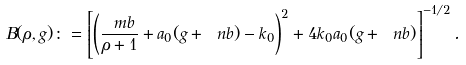<formula> <loc_0><loc_0><loc_500><loc_500>B ( \rho , g ) \colon = \left [ \left ( \frac { \ m b } { \rho + 1 } + a _ { 0 } ( g + \ n b ) - k _ { 0 } \right ) ^ { 2 } + 4 k _ { 0 } a _ { 0 } ( g + \ n b ) \right ] ^ { - 1 / 2 } .</formula> 